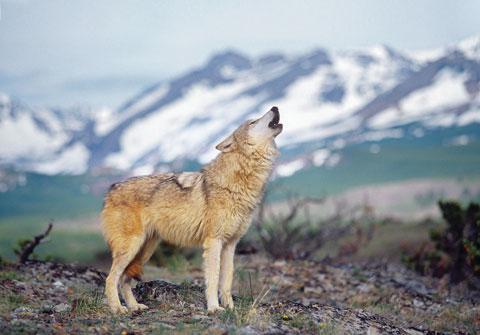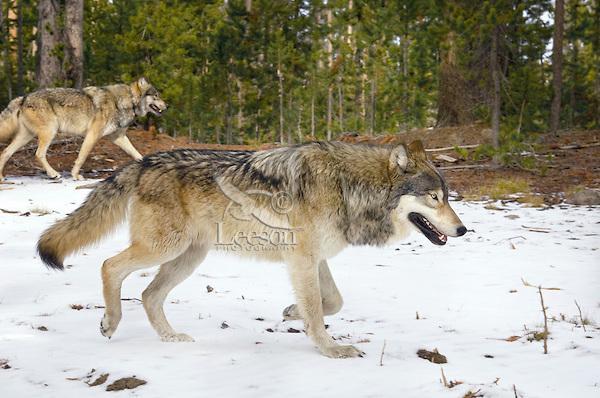The first image is the image on the left, the second image is the image on the right. Assess this claim about the two images: "The right image contains exactly two wolves.". Correct or not? Answer yes or no. Yes. The first image is the image on the left, the second image is the image on the right. Assess this claim about the two images: "In each image, multiple wolves interact playfully on a snowy field in front of evergreens.". Correct or not? Answer yes or no. No. 